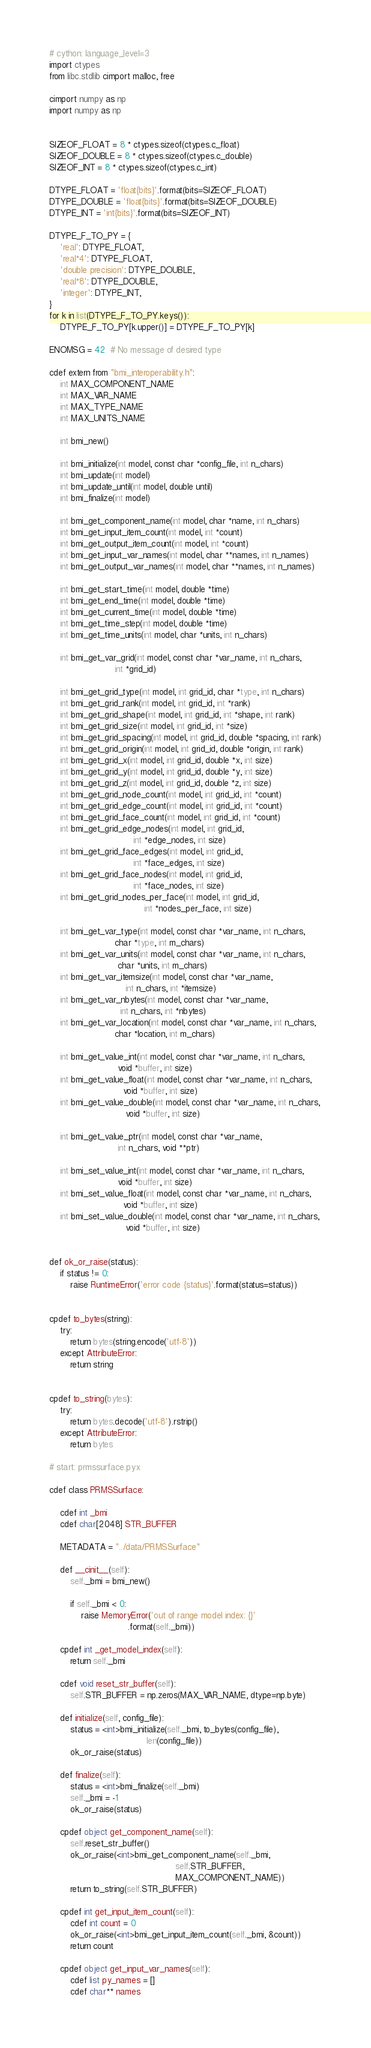<code> <loc_0><loc_0><loc_500><loc_500><_Cython_># cython: language_level=3
import ctypes
from libc.stdlib cimport malloc, free

cimport numpy as np
import numpy as np


SIZEOF_FLOAT = 8 * ctypes.sizeof(ctypes.c_float)
SIZEOF_DOUBLE = 8 * ctypes.sizeof(ctypes.c_double)
SIZEOF_INT = 8 * ctypes.sizeof(ctypes.c_int)

DTYPE_FLOAT = 'float{bits}'.format(bits=SIZEOF_FLOAT)
DTYPE_DOUBLE = 'float{bits}'.format(bits=SIZEOF_DOUBLE)
DTYPE_INT = 'int{bits}'.format(bits=SIZEOF_INT)

DTYPE_F_TO_PY = {
    'real': DTYPE_FLOAT,
    'real*4': DTYPE_FLOAT,
    'double precision': DTYPE_DOUBLE,
    'real*8': DTYPE_DOUBLE,
    'integer': DTYPE_INT,
}
for k in list(DTYPE_F_TO_PY.keys()):
    DTYPE_F_TO_PY[k.upper()] = DTYPE_F_TO_PY[k]

ENOMSG = 42  # No message of desired type

cdef extern from "bmi_interoperability.h":
    int MAX_COMPONENT_NAME
    int MAX_VAR_NAME
    int MAX_TYPE_NAME
    int MAX_UNITS_NAME

    int bmi_new()

    int bmi_initialize(int model, const char *config_file, int n_chars)
    int bmi_update(int model)
    int bmi_update_until(int model, double until)
    int bmi_finalize(int model)

    int bmi_get_component_name(int model, char *name, int n_chars)
    int bmi_get_input_item_count(int model, int *count)
    int bmi_get_output_item_count(int model, int *count)
    int bmi_get_input_var_names(int model, char **names, int n_names)
    int bmi_get_output_var_names(int model, char **names, int n_names)

    int bmi_get_start_time(int model, double *time)
    int bmi_get_end_time(int model, double *time)
    int bmi_get_current_time(int model, double *time)
    int bmi_get_time_step(int model, double *time)
    int bmi_get_time_units(int model, char *units, int n_chars)

    int bmi_get_var_grid(int model, const char *var_name, int n_chars,
                         int *grid_id)

    int bmi_get_grid_type(int model, int grid_id, char *type, int n_chars)
    int bmi_get_grid_rank(int model, int grid_id, int *rank)
    int bmi_get_grid_shape(int model, int grid_id, int *shape, int rank)
    int bmi_get_grid_size(int model, int grid_id, int *size)
    int bmi_get_grid_spacing(int model, int grid_id, double *spacing, int rank)
    int bmi_get_grid_origin(int model, int grid_id, double *origin, int rank)
    int bmi_get_grid_x(int model, int grid_id, double *x, int size)
    int bmi_get_grid_y(int model, int grid_id, double *y, int size)
    int bmi_get_grid_z(int model, int grid_id, double *z, int size)
    int bmi_get_grid_node_count(int model, int grid_id, int *count)
    int bmi_get_grid_edge_count(int model, int grid_id, int *count)
    int bmi_get_grid_face_count(int model, int grid_id, int *count)
    int bmi_get_grid_edge_nodes(int model, int grid_id,
                                int *edge_nodes, int size)
    int bmi_get_grid_face_edges(int model, int grid_id,
                                int *face_edges, int size)
    int bmi_get_grid_face_nodes(int model, int grid_id,
                                int *face_nodes, int size)
    int bmi_get_grid_nodes_per_face(int model, int grid_id,
                                    int *nodes_per_face, int size)

    int bmi_get_var_type(int model, const char *var_name, int n_chars,
                         char *type, int m_chars)
    int bmi_get_var_units(int model, const char *var_name, int n_chars,
                          char *units, int m_chars)
    int bmi_get_var_itemsize(int model, const char *var_name,
                             int n_chars, int *itemsize)
    int bmi_get_var_nbytes(int model, const char *var_name,
                           int n_chars, int *nbytes)
    int bmi_get_var_location(int model, const char *var_name, int n_chars,
                         char *location, int m_chars)

    int bmi_get_value_int(int model, const char *var_name, int n_chars,
                          void *buffer, int size)
    int bmi_get_value_float(int model, const char *var_name, int n_chars,
                            void *buffer, int size)
    int bmi_get_value_double(int model, const char *var_name, int n_chars,
                             void *buffer, int size)

    int bmi_get_value_ptr(int model, const char *var_name,
                          int n_chars, void **ptr)

    int bmi_set_value_int(int model, const char *var_name, int n_chars,
                          void *buffer, int size)
    int bmi_set_value_float(int model, const char *var_name, int n_chars,
                            void *buffer, int size)
    int bmi_set_value_double(int model, const char *var_name, int n_chars,
                             void *buffer, int size)


def ok_or_raise(status):
    if status != 0:
        raise RuntimeError('error code {status}'.format(status=status))


cpdef to_bytes(string):
    try:
        return bytes(string.encode('utf-8'))
    except AttributeError:
        return string


cpdef to_string(bytes):
    try:
        return bytes.decode('utf-8').rstrip()
    except AttributeError:
        return bytes

# start: prmssurface.pyx

cdef class PRMSSurface:

    cdef int _bmi
    cdef char[2048] STR_BUFFER

    METADATA = "../data/PRMSSurface"

    def __cinit__(self):
        self._bmi = bmi_new()

        if self._bmi < 0:
            raise MemoryError('out of range model index: {}'
                              .format(self._bmi))

    cpdef int _get_model_index(self):
        return self._bmi

    cdef void reset_str_buffer(self):
        self.STR_BUFFER = np.zeros(MAX_VAR_NAME, dtype=np.byte)

    def initialize(self, config_file):
        status = <int>bmi_initialize(self._bmi, to_bytes(config_file),
                                     len(config_file))
        ok_or_raise(status)

    def finalize(self):
        status = <int>bmi_finalize(self._bmi)
        self._bmi = -1
        ok_or_raise(status)

    cpdef object get_component_name(self):
        self.reset_str_buffer()
        ok_or_raise(<int>bmi_get_component_name(self._bmi,
                                                self.STR_BUFFER,
                                                MAX_COMPONENT_NAME))
        return to_string(self.STR_BUFFER)

    cpdef int get_input_item_count(self):
        cdef int count = 0
        ok_or_raise(<int>bmi_get_input_item_count(self._bmi, &count))
        return count

    cpdef object get_input_var_names(self):
        cdef list py_names = []
        cdef char** names</code> 